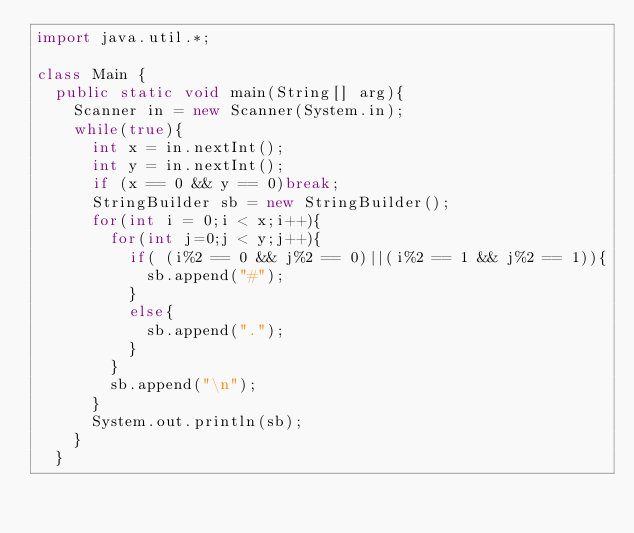<code> <loc_0><loc_0><loc_500><loc_500><_Java_>import java.util.*;

class Main {
	public static void main(String[] arg){
		Scanner in = new Scanner(System.in);
		while(true){
			int x = in.nextInt();	
			int y = in.nextInt();
			if (x == 0 && y == 0)break;
			StringBuilder sb = new StringBuilder();
			for(int i = 0;i < x;i++){
				for(int j=0;j < y;j++){
					if( (i%2 == 0 && j%2 == 0)||(i%2 == 1 && j%2 == 1)){
						sb.append("#");
					}
					else{
						sb.append(".");
					}
				}
				sb.append("\n");
			}
			System.out.println(sb);
		}	
	}</code> 